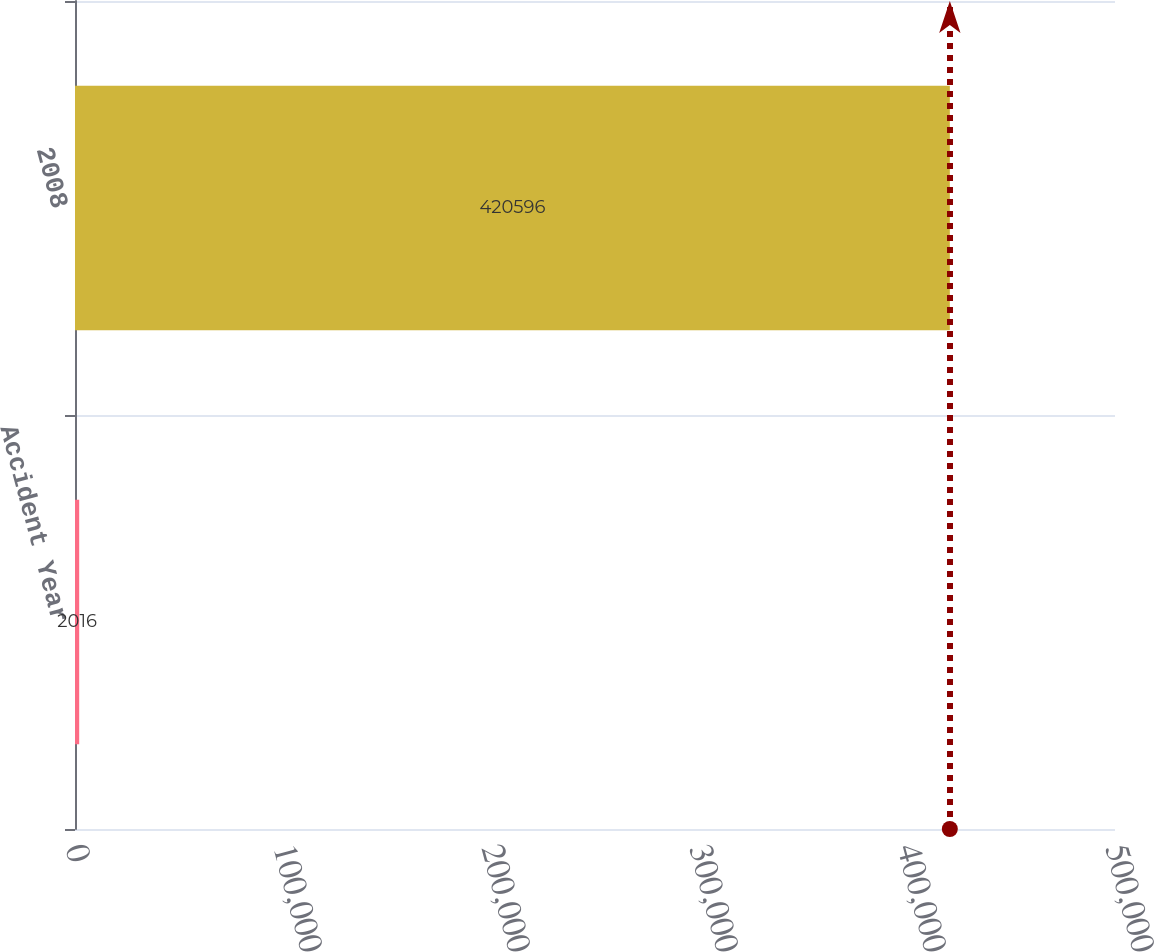Convert chart. <chart><loc_0><loc_0><loc_500><loc_500><bar_chart><fcel>Accident Year<fcel>2008<nl><fcel>2016<fcel>420596<nl></chart> 